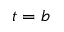Convert formula to latex. <formula><loc_0><loc_0><loc_500><loc_500>t = b</formula> 